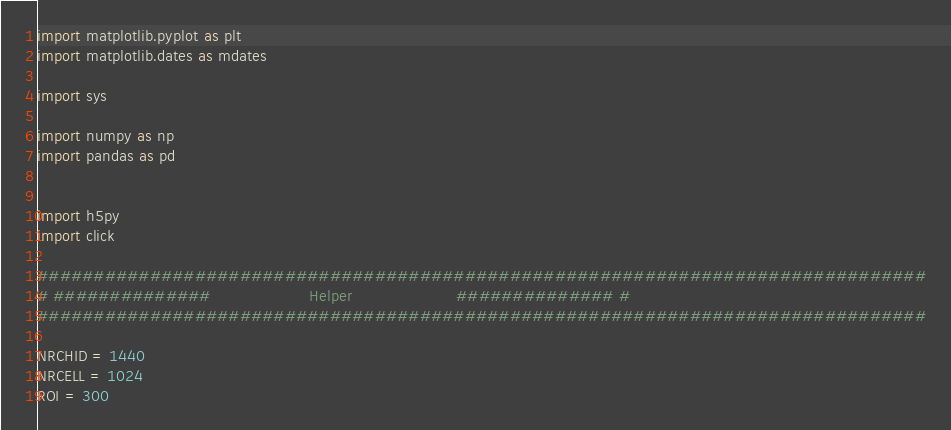<code> <loc_0><loc_0><loc_500><loc_500><_Python_>import matplotlib.pyplot as plt
import matplotlib.dates as mdates

import sys

import numpy as np
import pandas as pd


import h5py
import click

###############################################################################
# ##############                    Helper                     ############## #
###############################################################################

NRCHID = 1440
NRCELL = 1024
ROI = 300
</code> 